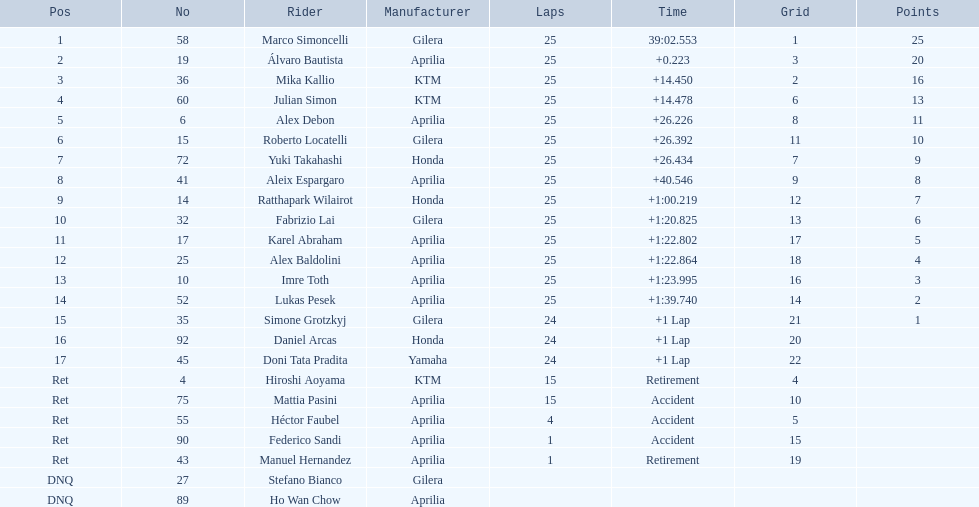What was the lap count for marco? 25. What was the lap count for hiroshi? 15. Which number is greater? 25. Who completed this higher number of laps? Marco Simoncelli. 